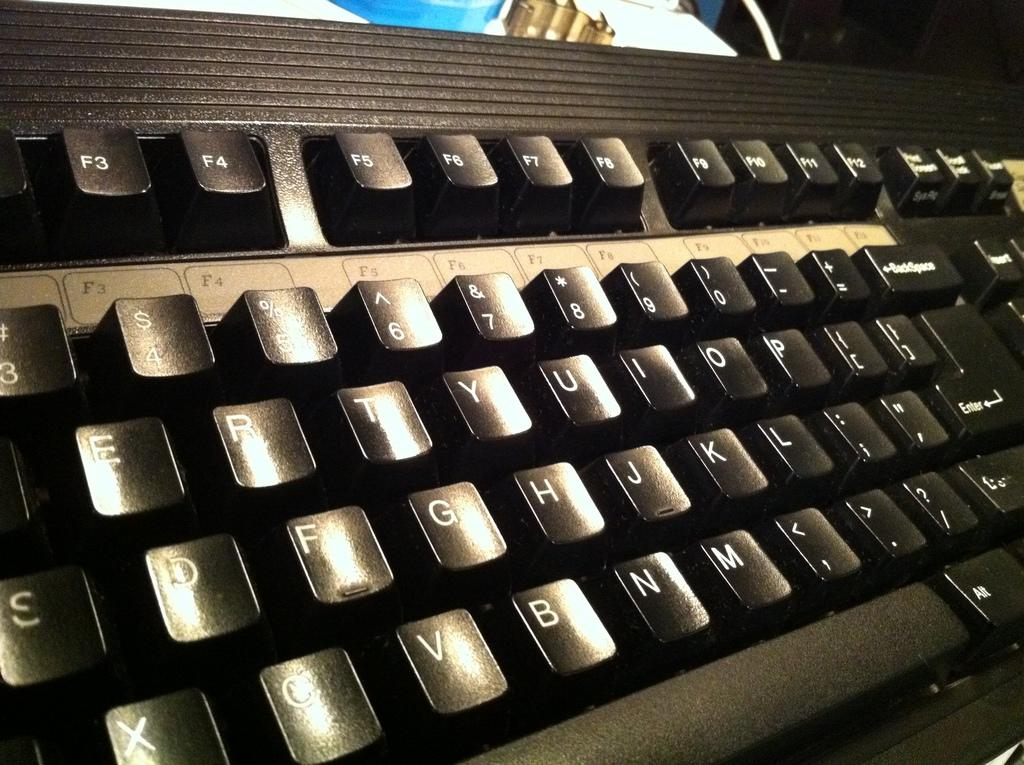<image>
Provide a brief description of the given image. A QWERTY style keyboard with the Function keys has a slight glare on it. 